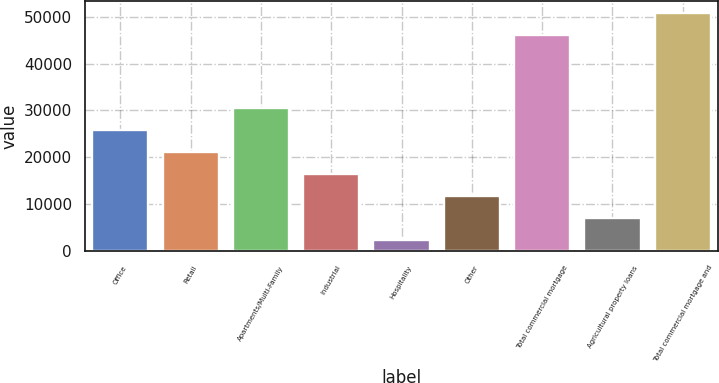Convert chart. <chart><loc_0><loc_0><loc_500><loc_500><bar_chart><fcel>Office<fcel>Retail<fcel>Apartments/Multi-Family<fcel>Industrial<fcel>Hospitality<fcel>Other<fcel>Total commercial mortgage<fcel>Agricultural property loans<fcel>Total commercial mortgage and<nl><fcel>25779.5<fcel>21126.2<fcel>30432.8<fcel>16472.9<fcel>2513<fcel>11819.6<fcel>46187<fcel>7166.3<fcel>50840.3<nl></chart> 